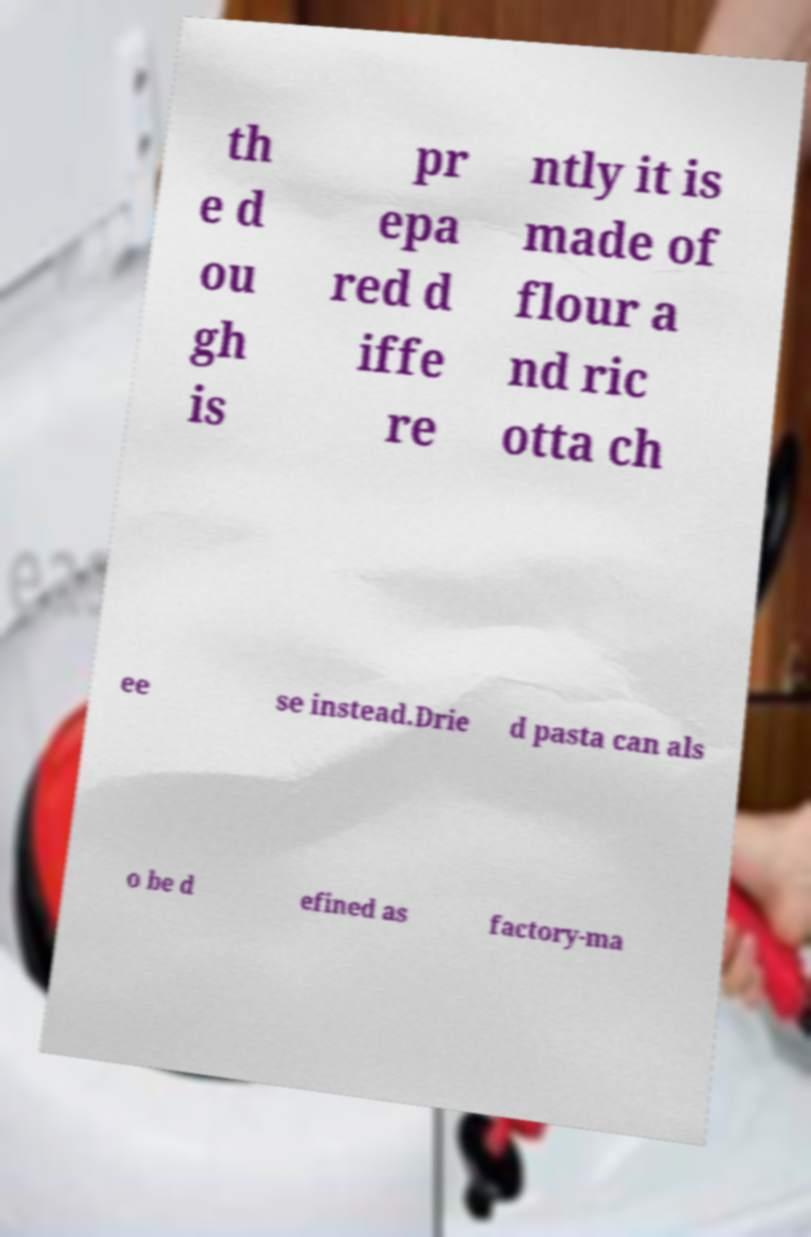Please read and relay the text visible in this image. What does it say? th e d ou gh is pr epa red d iffe re ntly it is made of flour a nd ric otta ch ee se instead.Drie d pasta can als o be d efined as factory-ma 